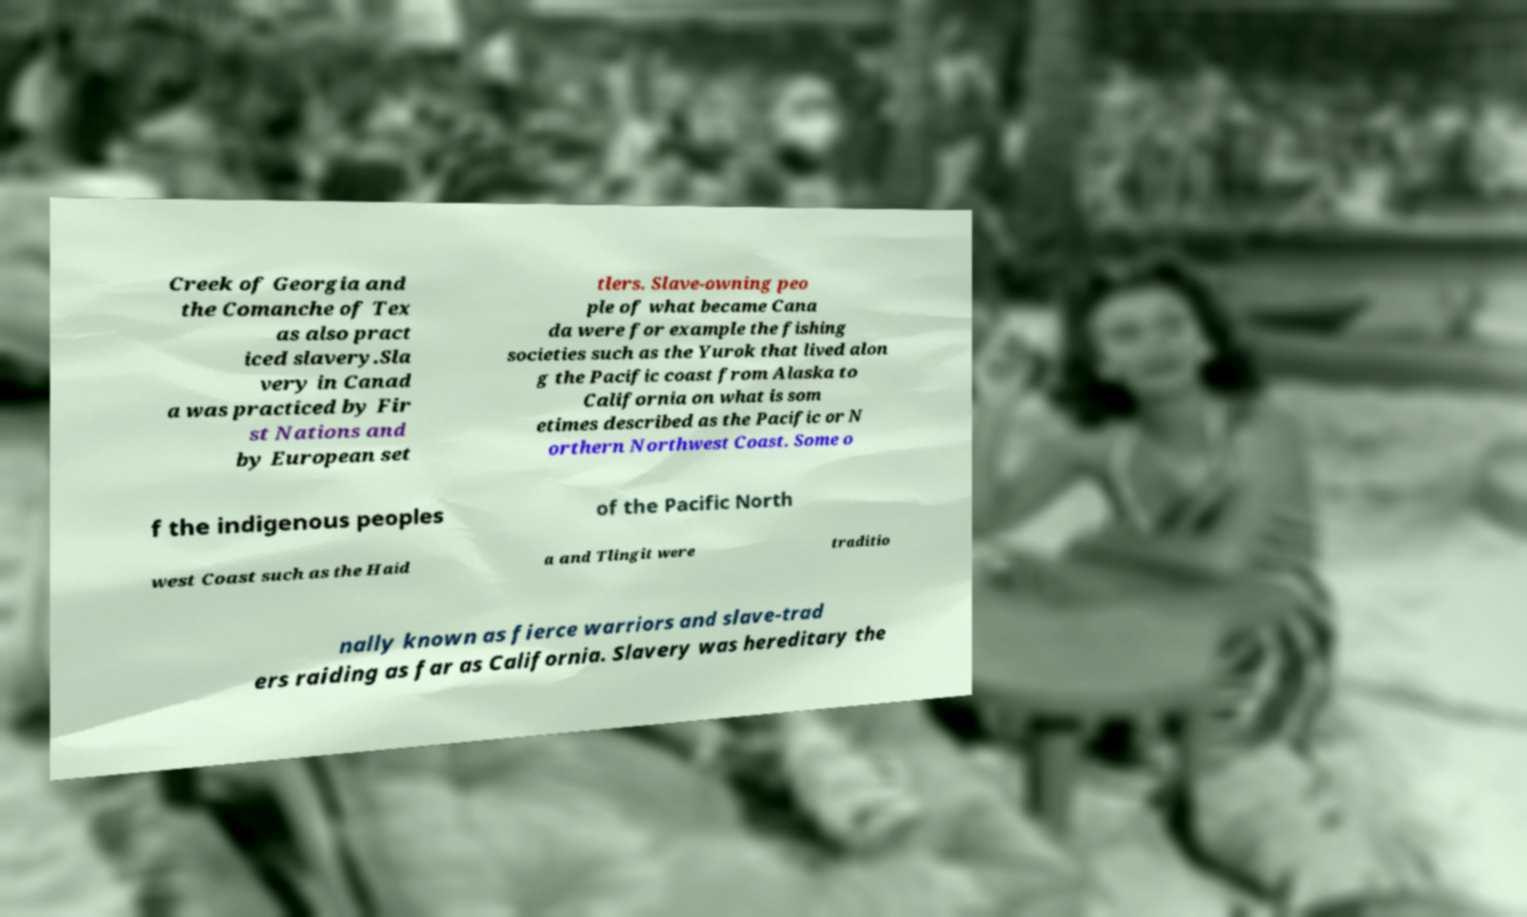Can you accurately transcribe the text from the provided image for me? Creek of Georgia and the Comanche of Tex as also pract iced slavery.Sla very in Canad a was practiced by Fir st Nations and by European set tlers. Slave-owning peo ple of what became Cana da were for example the fishing societies such as the Yurok that lived alon g the Pacific coast from Alaska to California on what is som etimes described as the Pacific or N orthern Northwest Coast. Some o f the indigenous peoples of the Pacific North west Coast such as the Haid a and Tlingit were traditio nally known as fierce warriors and slave-trad ers raiding as far as California. Slavery was hereditary the 